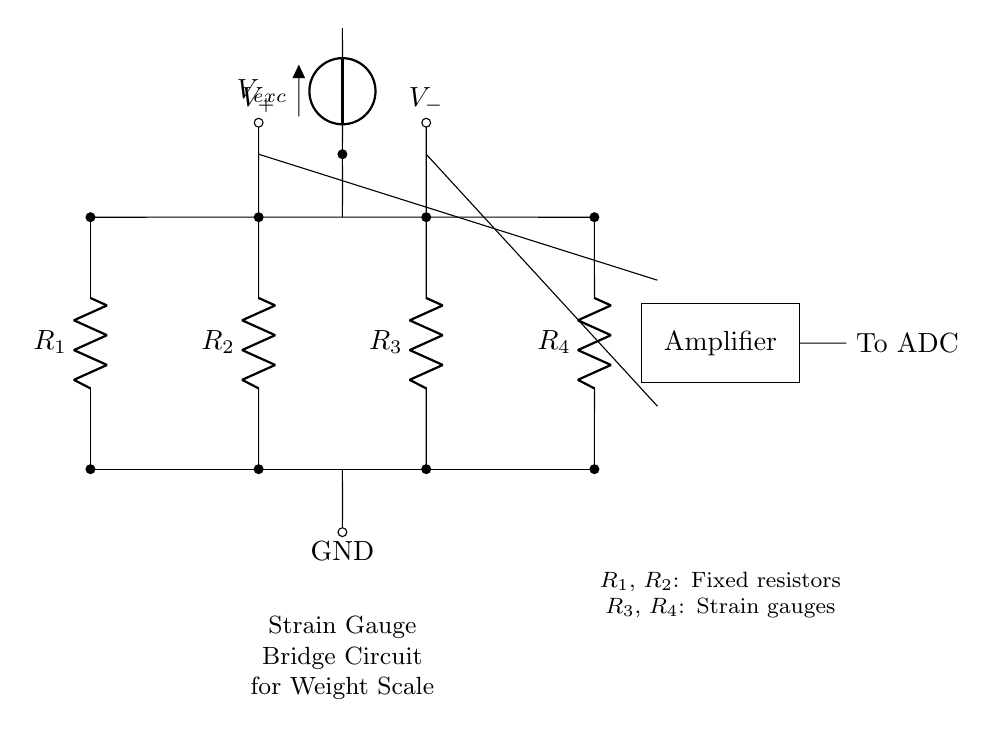What components are present in this circuit? The circuit contains four resistors and an amplifier. The resistors are labeled as R1, R2, R3, and R4, and the amplifier is depicted as a rectangular block in the diagram.
Answer: Four resistors and an amplifier What is the purpose of the voltage source V exc? The voltage source V exc provides excitation voltage to the strain gauge bridge circuit, necessary for the operation of the strain gauges, ensuring they can detect changes in resistance due to applied weight.
Answer: Excitation voltage How many strain gauges are used in this circuit? There are two strain gauges used in this circuit, which are represented by R3 and R4. They are part of the bridge configuration to measure the strain resulting from weight.
Answer: Two What is the output of the amplifier connected to? The output of the amplifier is connected to an analog-to-digital converter (ADC), which converts the amplified voltage signal into a digital format for further processing or display.
Answer: To ADC How does this bridge configuration help in measuring weight? The bridge configuration allows the comparison of resistances between the strain gauges and fixed resistors. When weight is applied, the strain gauges change their resistance, creating an imbalance that is detected and amplified, resulting in a measurable output voltage.
Answer: Measures weight through resistance change 